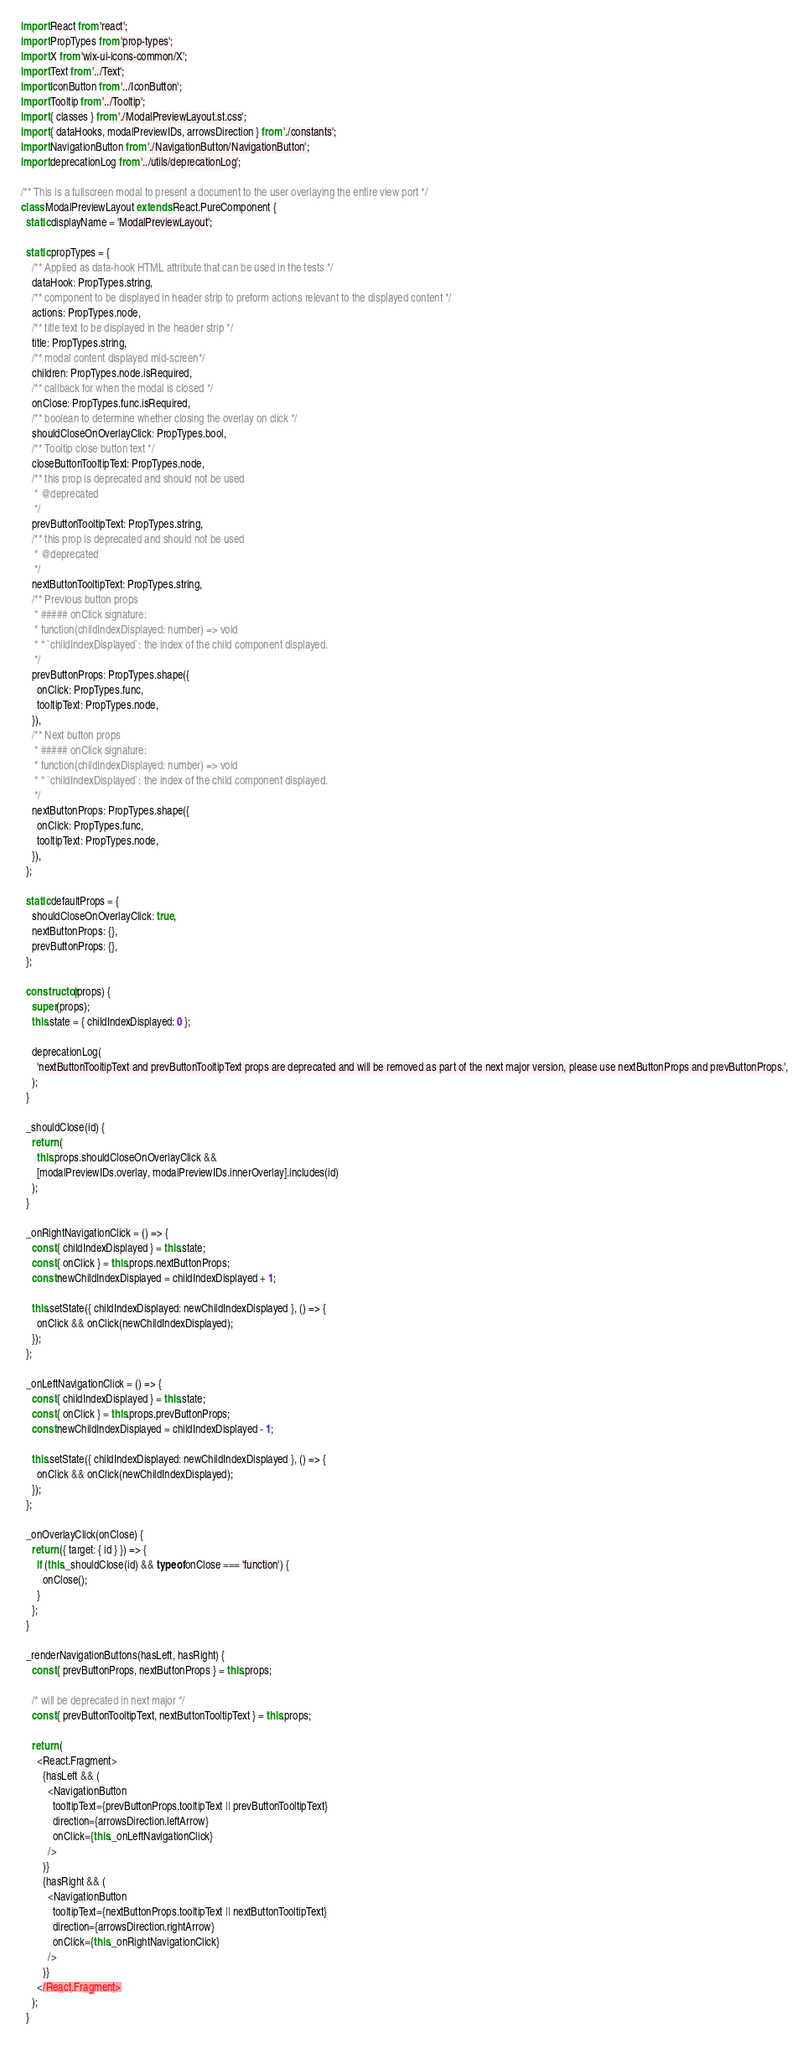<code> <loc_0><loc_0><loc_500><loc_500><_JavaScript_>import React from 'react';
import PropTypes from 'prop-types';
import X from 'wix-ui-icons-common/X';
import Text from '../Text';
import IconButton from '../IconButton';
import Tooltip from '../Tooltip';
import { classes } from './ModalPreviewLayout.st.css';
import { dataHooks, modalPreviewIDs, arrowsDirection } from './constants';
import NavigationButton from './NavigationButton/NavigationButton';
import deprecationLog from '../utils/deprecationLog';

/** This is a fullscreen modal to present a document to the user overlaying the entire view port */
class ModalPreviewLayout extends React.PureComponent {
  static displayName = 'ModalPreviewLayout';

  static propTypes = {
    /** Applied as data-hook HTML attribute that can be used in the tests */
    dataHook: PropTypes.string,
    /** component to be displayed in header strip to preform actions relevant to the displayed content */
    actions: PropTypes.node,
    /** title text to be displayed in the header strip */
    title: PropTypes.string,
    /** modal content displayed mid-screen*/
    children: PropTypes.node.isRequired,
    /** callback for when the modal is closed */
    onClose: PropTypes.func.isRequired,
    /** boolean to determine whether closing the overlay on click */
    shouldCloseOnOverlayClick: PropTypes.bool,
    /** Tooltip close button text */
    closeButtonTooltipText: PropTypes.node,
    /** this prop is deprecated and should not be used
     * @deprecated
     */
    prevButtonTooltipText: PropTypes.string,
    /** this prop is deprecated and should not be used
     * @deprecated
     */
    nextButtonTooltipText: PropTypes.string,
    /** Previous button props
     * ##### onClick signature:
     * function(childIndexDisplayed: number) => void
     * * `childIndexDisplayed`: the index of the child component displayed.
     */
    prevButtonProps: PropTypes.shape({
      onClick: PropTypes.func,
      tooltipText: PropTypes.node,
    }),
    /** Next button props
     * ##### onClick signature:
     * function(childIndexDisplayed: number) => void
     * * `childIndexDisplayed`: the index of the child component displayed.
     */
    nextButtonProps: PropTypes.shape({
      onClick: PropTypes.func,
      tooltipText: PropTypes.node,
    }),
  };

  static defaultProps = {
    shouldCloseOnOverlayClick: true,
    nextButtonProps: {},
    prevButtonProps: {},
  };

  constructor(props) {
    super(props);
    this.state = { childIndexDisplayed: 0 };

    deprecationLog(
      'nextButtonTooltipText and prevButtonTooltipText props are deprecated and will be removed as part of the next major version, please use nextButtonProps and prevButtonProps.',
    );
  }

  _shouldClose(id) {
    return (
      this.props.shouldCloseOnOverlayClick &&
      [modalPreviewIDs.overlay, modalPreviewIDs.innerOverlay].includes(id)
    );
  }

  _onRightNavigationClick = () => {
    const { childIndexDisplayed } = this.state;
    const { onClick } = this.props.nextButtonProps;
    const newChildIndexDisplayed = childIndexDisplayed + 1;

    this.setState({ childIndexDisplayed: newChildIndexDisplayed }, () => {
      onClick && onClick(newChildIndexDisplayed);
    });
  };

  _onLeftNavigationClick = () => {
    const { childIndexDisplayed } = this.state;
    const { onClick } = this.props.prevButtonProps;
    const newChildIndexDisplayed = childIndexDisplayed - 1;

    this.setState({ childIndexDisplayed: newChildIndexDisplayed }, () => {
      onClick && onClick(newChildIndexDisplayed);
    });
  };

  _onOverlayClick(onClose) {
    return ({ target: { id } }) => {
      if (this._shouldClose(id) && typeof onClose === 'function') {
        onClose();
      }
    };
  }

  _renderNavigationButtons(hasLeft, hasRight) {
    const { prevButtonProps, nextButtonProps } = this.props;

    /* will be deprecated in next major */
    const { prevButtonTooltipText, nextButtonTooltipText } = this.props;

    return (
      <React.Fragment>
        {hasLeft && (
          <NavigationButton
            tooltipText={prevButtonProps.tooltipText || prevButtonTooltipText}
            direction={arrowsDirection.leftArrow}
            onClick={this._onLeftNavigationClick}
          />
        )}
        {hasRight && (
          <NavigationButton
            tooltipText={nextButtonProps.tooltipText || nextButtonTooltipText}
            direction={arrowsDirection.rightArrow}
            onClick={this._onRightNavigationClick}
          />
        )}
      </React.Fragment>
    );
  }
</code> 